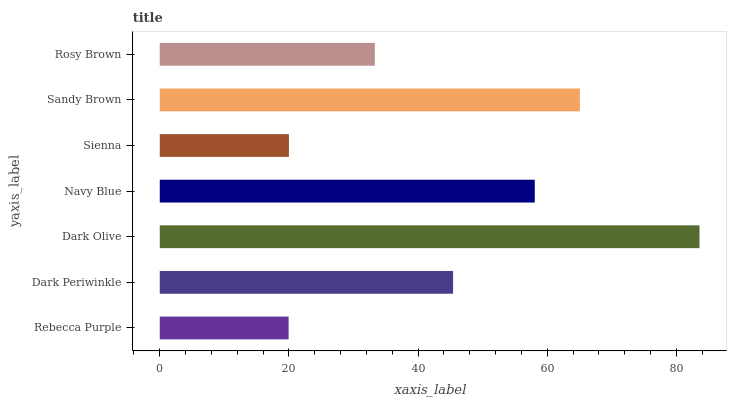Is Rebecca Purple the minimum?
Answer yes or no. Yes. Is Dark Olive the maximum?
Answer yes or no. Yes. Is Dark Periwinkle the minimum?
Answer yes or no. No. Is Dark Periwinkle the maximum?
Answer yes or no. No. Is Dark Periwinkle greater than Rebecca Purple?
Answer yes or no. Yes. Is Rebecca Purple less than Dark Periwinkle?
Answer yes or no. Yes. Is Rebecca Purple greater than Dark Periwinkle?
Answer yes or no. No. Is Dark Periwinkle less than Rebecca Purple?
Answer yes or no. No. Is Dark Periwinkle the high median?
Answer yes or no. Yes. Is Dark Periwinkle the low median?
Answer yes or no. Yes. Is Sienna the high median?
Answer yes or no. No. Is Sienna the low median?
Answer yes or no. No. 